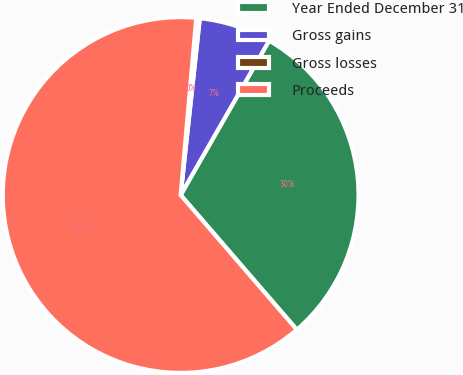<chart> <loc_0><loc_0><loc_500><loc_500><pie_chart><fcel>Year Ended December 31<fcel>Gross gains<fcel>Gross losses<fcel>Proceeds<nl><fcel>30.39%<fcel>6.56%<fcel>0.32%<fcel>62.73%<nl></chart> 